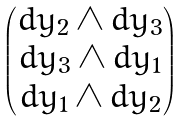<formula> <loc_0><loc_0><loc_500><loc_500>\begin{pmatrix} d y _ { 2 } \wedge d y _ { 3 } \\ d y _ { 3 } \wedge d y _ { 1 } \\ d y _ { 1 } \wedge d y _ { 2 } \end{pmatrix}</formula> 